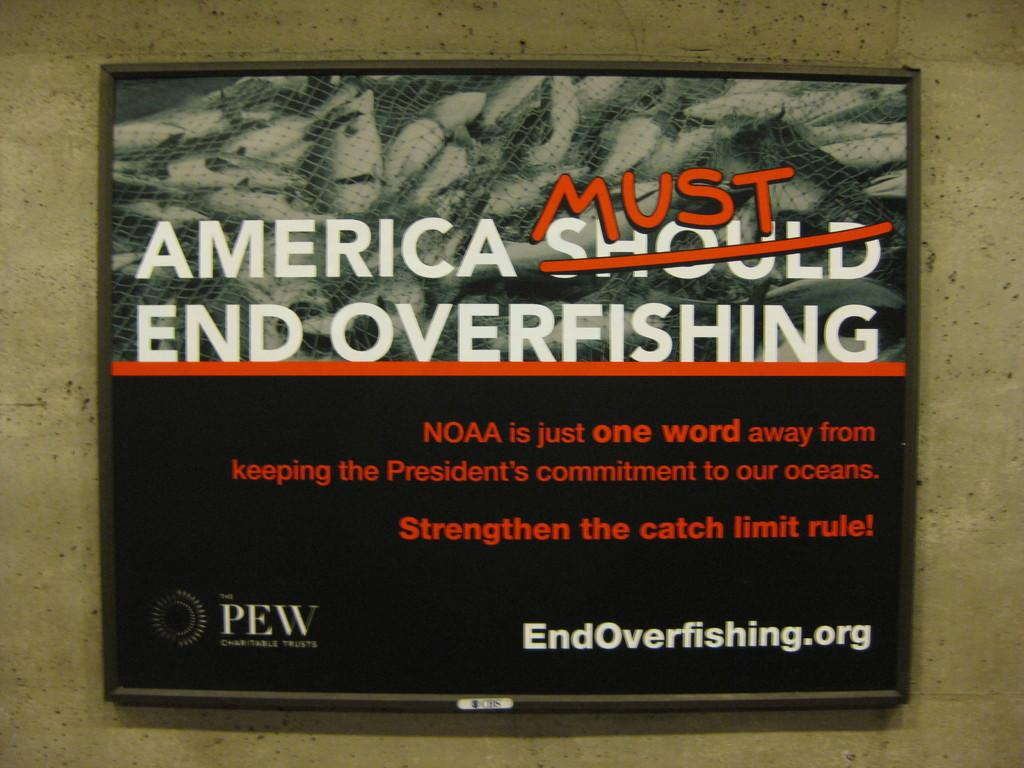<image>
Create a compact narrative representing the image presented. A sign by Endoverfishing.org that says "America Must End Overfishing" 